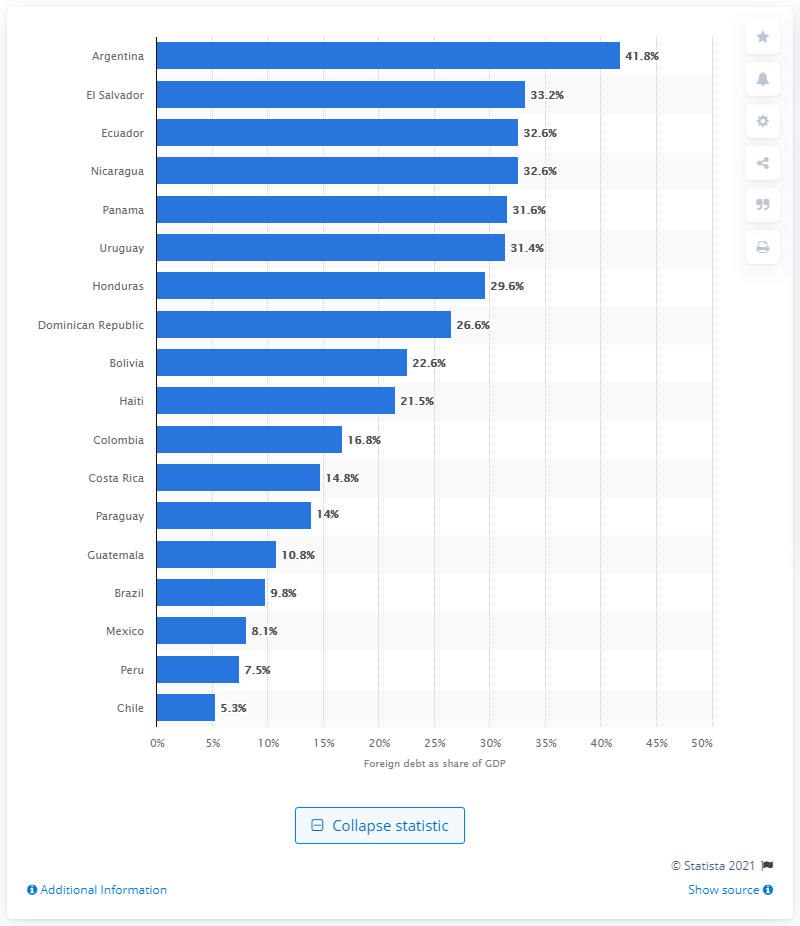Indicate a few pertinent items in this graphic. According to recent data, a significant portion of Argentina's Gross Domestic Product (GDP) is held by foreign creditors, amounting to 41.8%. According to this statistic, El Salvador ranked second among the countries listed. Argentina has the highest foreign debt in relation to its gross domestic product among Latin American countries. 